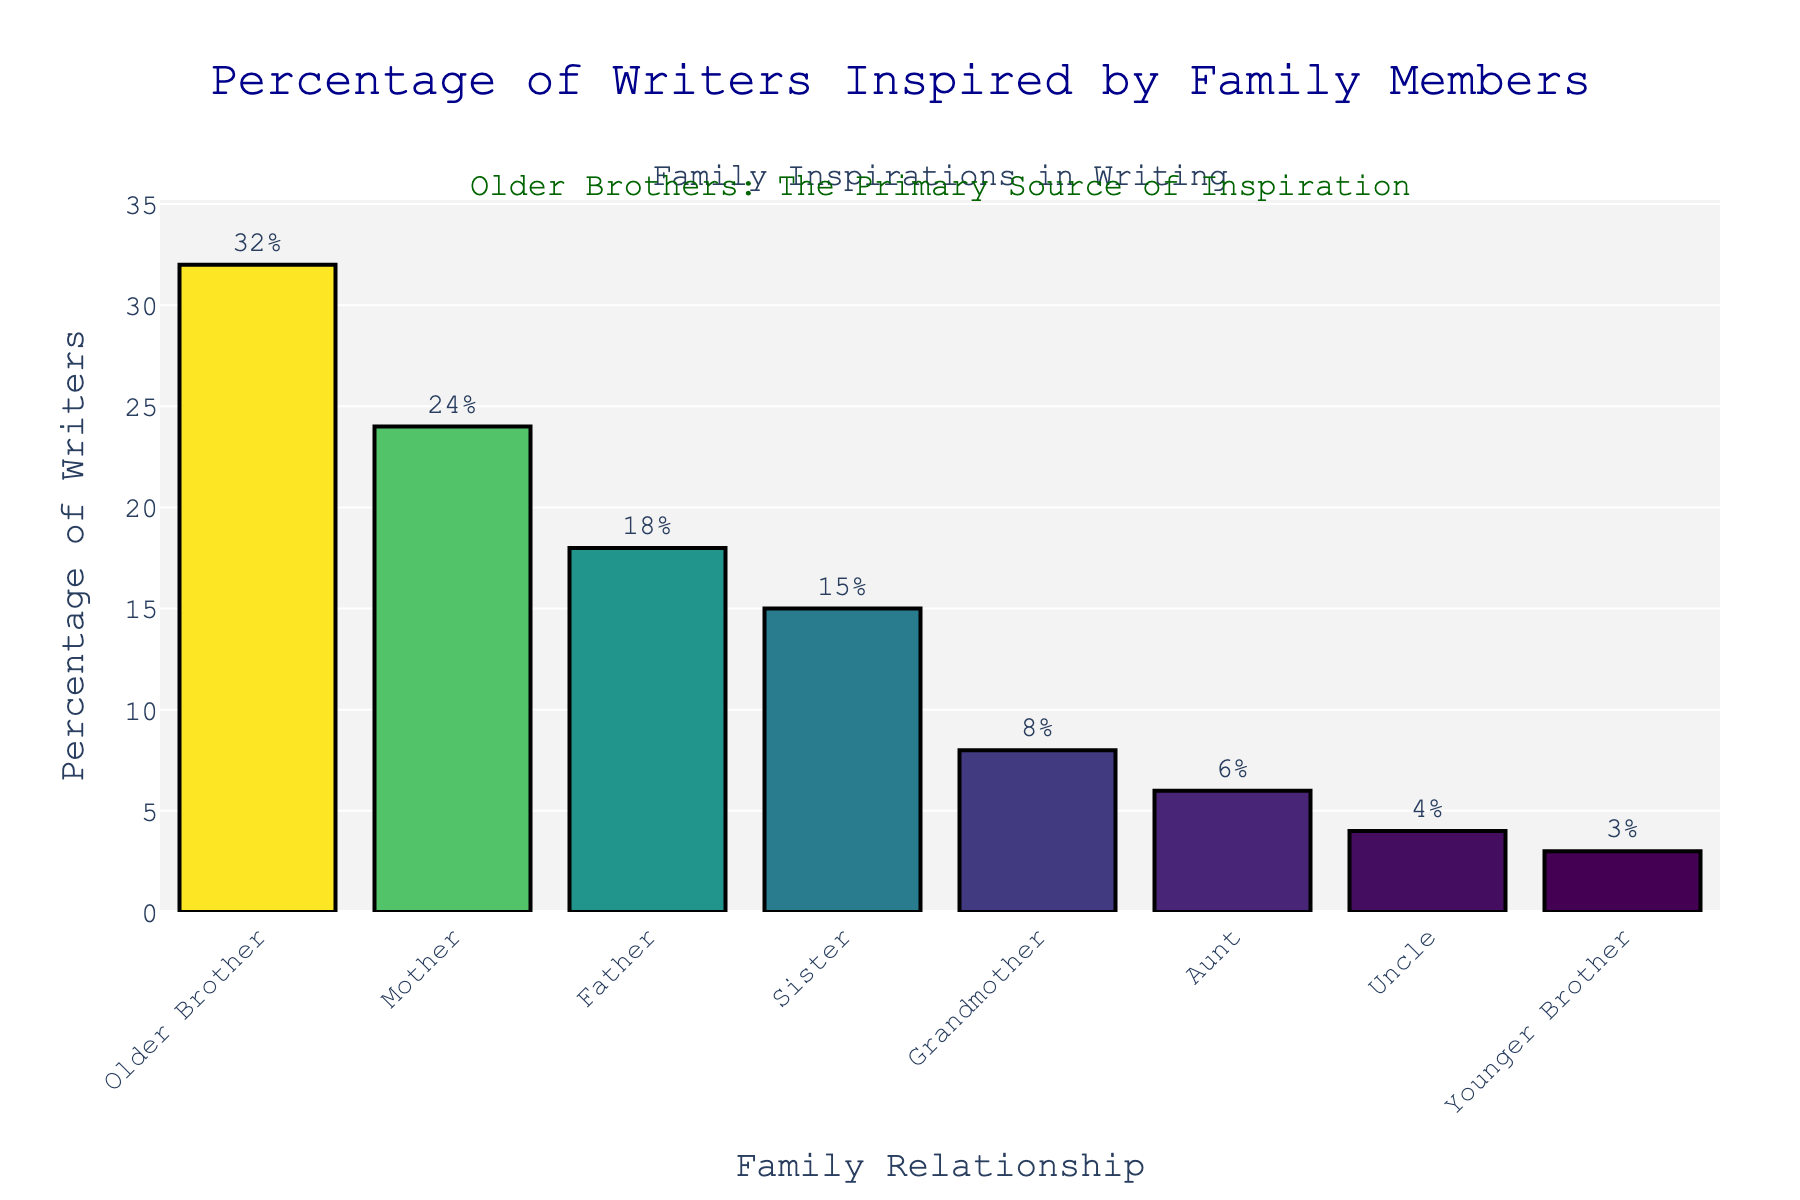What relationship type inspires the highest percentage of writers? To answer this, look at the height of the bars, and identify the one that is tallest. The "Older Brother" bar is the tallest with a value of 32%.
Answer: Older Brother Which two relationships together inspire more than half of the writers? Check the percentages and sum any combination of two relationships to find which combination exceeds 50%. "Older Brother" (32%) and "Mother" (24%) combined equal 56%.
Answer: Older Brother and Mother Which relationship is cited by fewer writers than the Grandmother but more than the Uncle? Compare the percentages for "Grandmother" (8%), "Uncle" (4%), and other relationships in between. "Aunt" has a value of 6%, fitting the criteria.
Answer: Aunt What is the difference in percentage between writers inspired by their Mother versus their Father? Subtract the percentage value of "Father" from "Mother". Mother (24%) - Father (18%) = 6%.
Answer: 6% How many relationships inspire less than 10% of writers? Identify and count the bars with a percentage less than 10%. Grandmother (8%), Aunt (6%), Uncle (4%), Younger Brother (3%) counts to 4 relationships.
Answer: 4 Does the sum of the percentages of writers inspired by their Sister and Father exceed 30%? Add the percentages for "Sister" (15%) and "Father" (18%). 15% + 18% = 33%, which is greater than 30%.
Answer: Yes Which relationship type has the smallest percentage of writers citing it as their primary inspiration? Identify the shortest bar, which is "Younger Brother" at 3%.
Answer: Younger Brother Are there more writers inspired by their Aunt than by their Uncle? Compare the percentages of "Aunt" (6%) and "Uncle" (4%). The percentage for the Aunt is higher.
Answer: Yes What is the total percentage of writers inspired by either an Older Brother or a Sister? Add the percentages of "Older Brother" (32%) and "Sister" (15%). 32% + 15% = 47%.
Answer: 47% Is the percentage of writers inspired by a Father closer to that inspired by a Mother or a Sister? Calculate the difference: Mother (24%) - Father (18%) = 6% and Sister (15%) - Father (18%) = 3%. The difference with Sister is smaller, so it's closer.
Answer: Sister 